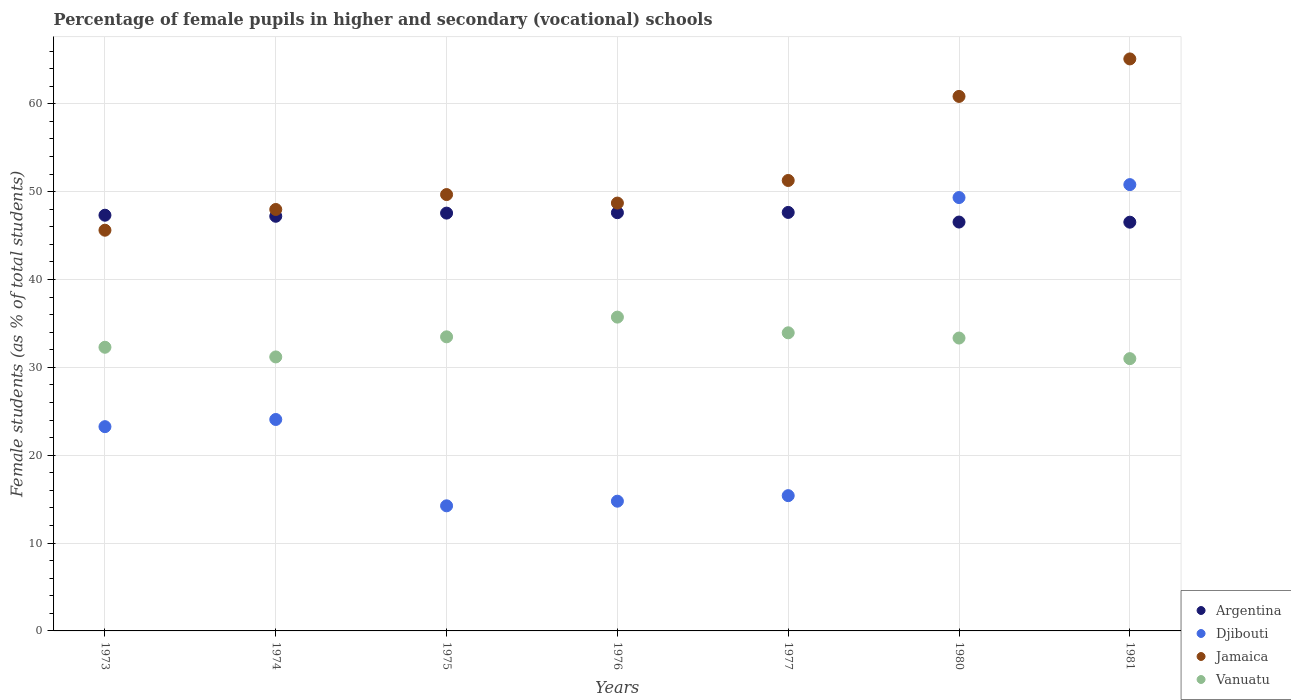How many different coloured dotlines are there?
Give a very brief answer. 4. Is the number of dotlines equal to the number of legend labels?
Your answer should be very brief. Yes. What is the percentage of female pupils in higher and secondary schools in Argentina in 1974?
Ensure brevity in your answer.  47.19. Across all years, what is the maximum percentage of female pupils in higher and secondary schools in Vanuatu?
Offer a terse response. 35.71. Across all years, what is the minimum percentage of female pupils in higher and secondary schools in Vanuatu?
Give a very brief answer. 30.99. In which year was the percentage of female pupils in higher and secondary schools in Djibouti maximum?
Give a very brief answer. 1981. In which year was the percentage of female pupils in higher and secondary schools in Jamaica minimum?
Ensure brevity in your answer.  1973. What is the total percentage of female pupils in higher and secondary schools in Djibouti in the graph?
Provide a succinct answer. 191.83. What is the difference between the percentage of female pupils in higher and secondary schools in Djibouti in 1976 and that in 1981?
Keep it short and to the point. -36.03. What is the difference between the percentage of female pupils in higher and secondary schools in Argentina in 1981 and the percentage of female pupils in higher and secondary schools in Vanuatu in 1977?
Your answer should be compact. 12.59. What is the average percentage of female pupils in higher and secondary schools in Jamaica per year?
Your response must be concise. 52.73. In the year 1977, what is the difference between the percentage of female pupils in higher and secondary schools in Argentina and percentage of female pupils in higher and secondary schools in Vanuatu?
Ensure brevity in your answer.  13.7. In how many years, is the percentage of female pupils in higher and secondary schools in Argentina greater than 2 %?
Ensure brevity in your answer.  7. What is the ratio of the percentage of female pupils in higher and secondary schools in Vanuatu in 1975 to that in 1980?
Your response must be concise. 1. Is the percentage of female pupils in higher and secondary schools in Jamaica in 1975 less than that in 1976?
Make the answer very short. No. What is the difference between the highest and the second highest percentage of female pupils in higher and secondary schools in Jamaica?
Give a very brief answer. 4.27. What is the difference between the highest and the lowest percentage of female pupils in higher and secondary schools in Vanuatu?
Your answer should be very brief. 4.73. In how many years, is the percentage of female pupils in higher and secondary schools in Djibouti greater than the average percentage of female pupils in higher and secondary schools in Djibouti taken over all years?
Your answer should be compact. 2. Is it the case that in every year, the sum of the percentage of female pupils in higher and secondary schools in Vanuatu and percentage of female pupils in higher and secondary schools in Argentina  is greater than the sum of percentage of female pupils in higher and secondary schools in Jamaica and percentage of female pupils in higher and secondary schools in Djibouti?
Offer a very short reply. Yes. Does the percentage of female pupils in higher and secondary schools in Vanuatu monotonically increase over the years?
Make the answer very short. No. Is the percentage of female pupils in higher and secondary schools in Djibouti strictly less than the percentage of female pupils in higher and secondary schools in Jamaica over the years?
Your answer should be very brief. Yes. What is the difference between two consecutive major ticks on the Y-axis?
Offer a terse response. 10. Are the values on the major ticks of Y-axis written in scientific E-notation?
Make the answer very short. No. Does the graph contain grids?
Keep it short and to the point. Yes. What is the title of the graph?
Offer a very short reply. Percentage of female pupils in higher and secondary (vocational) schools. What is the label or title of the X-axis?
Provide a succinct answer. Years. What is the label or title of the Y-axis?
Your answer should be very brief. Female students (as % of total students). What is the Female students (as % of total students) of Argentina in 1973?
Your response must be concise. 47.31. What is the Female students (as % of total students) of Djibouti in 1973?
Your response must be concise. 23.25. What is the Female students (as % of total students) of Jamaica in 1973?
Make the answer very short. 45.61. What is the Female students (as % of total students) of Vanuatu in 1973?
Give a very brief answer. 32.28. What is the Female students (as % of total students) in Argentina in 1974?
Offer a terse response. 47.19. What is the Female students (as % of total students) of Djibouti in 1974?
Ensure brevity in your answer.  24.06. What is the Female students (as % of total students) in Jamaica in 1974?
Offer a terse response. 47.97. What is the Female students (as % of total students) of Vanuatu in 1974?
Offer a very short reply. 31.18. What is the Female students (as % of total students) in Argentina in 1975?
Provide a succinct answer. 47.55. What is the Female students (as % of total students) in Djibouti in 1975?
Ensure brevity in your answer.  14.24. What is the Female students (as % of total students) in Jamaica in 1975?
Offer a terse response. 49.66. What is the Female students (as % of total students) in Vanuatu in 1975?
Ensure brevity in your answer.  33.47. What is the Female students (as % of total students) in Argentina in 1976?
Offer a very short reply. 47.6. What is the Female students (as % of total students) of Djibouti in 1976?
Provide a short and direct response. 14.77. What is the Female students (as % of total students) of Jamaica in 1976?
Make the answer very short. 48.69. What is the Female students (as % of total students) of Vanuatu in 1976?
Your response must be concise. 35.71. What is the Female students (as % of total students) in Argentina in 1977?
Your answer should be very brief. 47.63. What is the Female students (as % of total students) in Djibouti in 1977?
Provide a short and direct response. 15.4. What is the Female students (as % of total students) of Jamaica in 1977?
Provide a short and direct response. 51.27. What is the Female students (as % of total students) in Vanuatu in 1977?
Your answer should be very brief. 33.93. What is the Female students (as % of total students) of Argentina in 1980?
Ensure brevity in your answer.  46.53. What is the Female students (as % of total students) in Djibouti in 1980?
Your answer should be compact. 49.32. What is the Female students (as % of total students) of Jamaica in 1980?
Make the answer very short. 60.83. What is the Female students (as % of total students) of Vanuatu in 1980?
Offer a terse response. 33.33. What is the Female students (as % of total students) in Argentina in 1981?
Make the answer very short. 46.52. What is the Female students (as % of total students) in Djibouti in 1981?
Ensure brevity in your answer.  50.79. What is the Female students (as % of total students) of Jamaica in 1981?
Give a very brief answer. 65.1. What is the Female students (as % of total students) of Vanuatu in 1981?
Your answer should be compact. 30.99. Across all years, what is the maximum Female students (as % of total students) of Argentina?
Offer a terse response. 47.63. Across all years, what is the maximum Female students (as % of total students) in Djibouti?
Offer a terse response. 50.79. Across all years, what is the maximum Female students (as % of total students) of Jamaica?
Offer a very short reply. 65.1. Across all years, what is the maximum Female students (as % of total students) in Vanuatu?
Your answer should be compact. 35.71. Across all years, what is the minimum Female students (as % of total students) of Argentina?
Your answer should be compact. 46.52. Across all years, what is the minimum Female students (as % of total students) of Djibouti?
Keep it short and to the point. 14.24. Across all years, what is the minimum Female students (as % of total students) of Jamaica?
Your answer should be compact. 45.61. Across all years, what is the minimum Female students (as % of total students) in Vanuatu?
Give a very brief answer. 30.99. What is the total Female students (as % of total students) in Argentina in the graph?
Offer a very short reply. 330.34. What is the total Female students (as % of total students) in Djibouti in the graph?
Provide a short and direct response. 191.83. What is the total Female students (as % of total students) in Jamaica in the graph?
Offer a very short reply. 369.13. What is the total Female students (as % of total students) in Vanuatu in the graph?
Provide a succinct answer. 230.9. What is the difference between the Female students (as % of total students) of Argentina in 1973 and that in 1974?
Your answer should be very brief. 0.12. What is the difference between the Female students (as % of total students) of Djibouti in 1973 and that in 1974?
Keep it short and to the point. -0.82. What is the difference between the Female students (as % of total students) of Jamaica in 1973 and that in 1974?
Offer a terse response. -2.36. What is the difference between the Female students (as % of total students) of Vanuatu in 1973 and that in 1974?
Keep it short and to the point. 1.1. What is the difference between the Female students (as % of total students) in Argentina in 1973 and that in 1975?
Provide a succinct answer. -0.24. What is the difference between the Female students (as % of total students) of Djibouti in 1973 and that in 1975?
Your response must be concise. 9.01. What is the difference between the Female students (as % of total students) in Jamaica in 1973 and that in 1975?
Offer a very short reply. -4.06. What is the difference between the Female students (as % of total students) of Vanuatu in 1973 and that in 1975?
Give a very brief answer. -1.19. What is the difference between the Female students (as % of total students) of Argentina in 1973 and that in 1976?
Your answer should be compact. -0.29. What is the difference between the Female students (as % of total students) of Djibouti in 1973 and that in 1976?
Give a very brief answer. 8.48. What is the difference between the Female students (as % of total students) of Jamaica in 1973 and that in 1976?
Keep it short and to the point. -3.09. What is the difference between the Female students (as % of total students) in Vanuatu in 1973 and that in 1976?
Make the answer very short. -3.43. What is the difference between the Female students (as % of total students) in Argentina in 1973 and that in 1977?
Provide a short and direct response. -0.32. What is the difference between the Female students (as % of total students) in Djibouti in 1973 and that in 1977?
Make the answer very short. 7.85. What is the difference between the Female students (as % of total students) in Jamaica in 1973 and that in 1977?
Give a very brief answer. -5.66. What is the difference between the Female students (as % of total students) of Vanuatu in 1973 and that in 1977?
Give a very brief answer. -1.65. What is the difference between the Female students (as % of total students) of Argentina in 1973 and that in 1980?
Ensure brevity in your answer.  0.78. What is the difference between the Female students (as % of total students) in Djibouti in 1973 and that in 1980?
Your response must be concise. -26.07. What is the difference between the Female students (as % of total students) in Jamaica in 1973 and that in 1980?
Your response must be concise. -15.23. What is the difference between the Female students (as % of total students) of Vanuatu in 1973 and that in 1980?
Offer a very short reply. -1.05. What is the difference between the Female students (as % of total students) of Argentina in 1973 and that in 1981?
Make the answer very short. 0.79. What is the difference between the Female students (as % of total students) in Djibouti in 1973 and that in 1981?
Provide a short and direct response. -27.55. What is the difference between the Female students (as % of total students) in Jamaica in 1973 and that in 1981?
Your response must be concise. -19.49. What is the difference between the Female students (as % of total students) of Vanuatu in 1973 and that in 1981?
Provide a short and direct response. 1.3. What is the difference between the Female students (as % of total students) in Argentina in 1974 and that in 1975?
Offer a very short reply. -0.36. What is the difference between the Female students (as % of total students) of Djibouti in 1974 and that in 1975?
Make the answer very short. 9.83. What is the difference between the Female students (as % of total students) of Jamaica in 1974 and that in 1975?
Make the answer very short. -1.7. What is the difference between the Female students (as % of total students) in Vanuatu in 1974 and that in 1975?
Your response must be concise. -2.29. What is the difference between the Female students (as % of total students) in Argentina in 1974 and that in 1976?
Your answer should be compact. -0.41. What is the difference between the Female students (as % of total students) of Djibouti in 1974 and that in 1976?
Your answer should be compact. 9.3. What is the difference between the Female students (as % of total students) of Jamaica in 1974 and that in 1976?
Your answer should be very brief. -0.73. What is the difference between the Female students (as % of total students) in Vanuatu in 1974 and that in 1976?
Your answer should be compact. -4.53. What is the difference between the Female students (as % of total students) in Argentina in 1974 and that in 1977?
Provide a short and direct response. -0.44. What is the difference between the Female students (as % of total students) of Djibouti in 1974 and that in 1977?
Your answer should be compact. 8.67. What is the difference between the Female students (as % of total students) of Jamaica in 1974 and that in 1977?
Ensure brevity in your answer.  -3.3. What is the difference between the Female students (as % of total students) of Vanuatu in 1974 and that in 1977?
Offer a terse response. -2.75. What is the difference between the Female students (as % of total students) in Argentina in 1974 and that in 1980?
Offer a terse response. 0.66. What is the difference between the Female students (as % of total students) in Djibouti in 1974 and that in 1980?
Provide a succinct answer. -25.26. What is the difference between the Female students (as % of total students) of Jamaica in 1974 and that in 1980?
Your response must be concise. -12.87. What is the difference between the Female students (as % of total students) in Vanuatu in 1974 and that in 1980?
Give a very brief answer. -2.15. What is the difference between the Female students (as % of total students) of Argentina in 1974 and that in 1981?
Offer a terse response. 0.67. What is the difference between the Female students (as % of total students) of Djibouti in 1974 and that in 1981?
Provide a succinct answer. -26.73. What is the difference between the Female students (as % of total students) in Jamaica in 1974 and that in 1981?
Your answer should be very brief. -17.13. What is the difference between the Female students (as % of total students) of Vanuatu in 1974 and that in 1981?
Offer a very short reply. 0.19. What is the difference between the Female students (as % of total students) in Argentina in 1975 and that in 1976?
Your response must be concise. -0.05. What is the difference between the Female students (as % of total students) of Djibouti in 1975 and that in 1976?
Offer a terse response. -0.53. What is the difference between the Female students (as % of total students) of Jamaica in 1975 and that in 1976?
Give a very brief answer. 0.97. What is the difference between the Female students (as % of total students) in Vanuatu in 1975 and that in 1976?
Your answer should be compact. -2.24. What is the difference between the Female students (as % of total students) in Argentina in 1975 and that in 1977?
Ensure brevity in your answer.  -0.08. What is the difference between the Female students (as % of total students) of Djibouti in 1975 and that in 1977?
Provide a short and direct response. -1.16. What is the difference between the Female students (as % of total students) of Jamaica in 1975 and that in 1977?
Give a very brief answer. -1.6. What is the difference between the Female students (as % of total students) in Vanuatu in 1975 and that in 1977?
Provide a short and direct response. -0.46. What is the difference between the Female students (as % of total students) of Argentina in 1975 and that in 1980?
Your response must be concise. 1.02. What is the difference between the Female students (as % of total students) of Djibouti in 1975 and that in 1980?
Your answer should be very brief. -35.08. What is the difference between the Female students (as % of total students) in Jamaica in 1975 and that in 1980?
Provide a succinct answer. -11.17. What is the difference between the Female students (as % of total students) of Vanuatu in 1975 and that in 1980?
Ensure brevity in your answer.  0.14. What is the difference between the Female students (as % of total students) of Argentina in 1975 and that in 1981?
Provide a succinct answer. 1.03. What is the difference between the Female students (as % of total students) of Djibouti in 1975 and that in 1981?
Keep it short and to the point. -36.56. What is the difference between the Female students (as % of total students) of Jamaica in 1975 and that in 1981?
Your answer should be compact. -15.44. What is the difference between the Female students (as % of total students) in Vanuatu in 1975 and that in 1981?
Make the answer very short. 2.48. What is the difference between the Female students (as % of total students) of Argentina in 1976 and that in 1977?
Offer a very short reply. -0.03. What is the difference between the Female students (as % of total students) in Djibouti in 1976 and that in 1977?
Give a very brief answer. -0.63. What is the difference between the Female students (as % of total students) in Jamaica in 1976 and that in 1977?
Make the answer very short. -2.57. What is the difference between the Female students (as % of total students) in Vanuatu in 1976 and that in 1977?
Keep it short and to the point. 1.79. What is the difference between the Female students (as % of total students) in Argentina in 1976 and that in 1980?
Give a very brief answer. 1.06. What is the difference between the Female students (as % of total students) in Djibouti in 1976 and that in 1980?
Offer a terse response. -34.56. What is the difference between the Female students (as % of total students) in Jamaica in 1976 and that in 1980?
Give a very brief answer. -12.14. What is the difference between the Female students (as % of total students) of Vanuatu in 1976 and that in 1980?
Make the answer very short. 2.38. What is the difference between the Female students (as % of total students) in Argentina in 1976 and that in 1981?
Make the answer very short. 1.08. What is the difference between the Female students (as % of total students) of Djibouti in 1976 and that in 1981?
Your answer should be very brief. -36.03. What is the difference between the Female students (as % of total students) of Jamaica in 1976 and that in 1981?
Offer a very short reply. -16.41. What is the difference between the Female students (as % of total students) in Vanuatu in 1976 and that in 1981?
Your answer should be very brief. 4.73. What is the difference between the Female students (as % of total students) in Argentina in 1977 and that in 1980?
Offer a terse response. 1.09. What is the difference between the Female students (as % of total students) of Djibouti in 1977 and that in 1980?
Your response must be concise. -33.93. What is the difference between the Female students (as % of total students) of Jamaica in 1977 and that in 1980?
Keep it short and to the point. -9.57. What is the difference between the Female students (as % of total students) of Vanuatu in 1977 and that in 1980?
Your response must be concise. 0.6. What is the difference between the Female students (as % of total students) of Argentina in 1977 and that in 1981?
Ensure brevity in your answer.  1.11. What is the difference between the Female students (as % of total students) in Djibouti in 1977 and that in 1981?
Give a very brief answer. -35.4. What is the difference between the Female students (as % of total students) of Jamaica in 1977 and that in 1981?
Offer a very short reply. -13.83. What is the difference between the Female students (as % of total students) of Vanuatu in 1977 and that in 1981?
Provide a short and direct response. 2.94. What is the difference between the Female students (as % of total students) in Argentina in 1980 and that in 1981?
Offer a terse response. 0.02. What is the difference between the Female students (as % of total students) of Djibouti in 1980 and that in 1981?
Your answer should be compact. -1.47. What is the difference between the Female students (as % of total students) of Jamaica in 1980 and that in 1981?
Give a very brief answer. -4.27. What is the difference between the Female students (as % of total students) in Vanuatu in 1980 and that in 1981?
Your answer should be compact. 2.35. What is the difference between the Female students (as % of total students) of Argentina in 1973 and the Female students (as % of total students) of Djibouti in 1974?
Give a very brief answer. 23.25. What is the difference between the Female students (as % of total students) in Argentina in 1973 and the Female students (as % of total students) in Jamaica in 1974?
Keep it short and to the point. -0.65. What is the difference between the Female students (as % of total students) in Argentina in 1973 and the Female students (as % of total students) in Vanuatu in 1974?
Offer a terse response. 16.13. What is the difference between the Female students (as % of total students) of Djibouti in 1973 and the Female students (as % of total students) of Jamaica in 1974?
Your answer should be very brief. -24.72. What is the difference between the Female students (as % of total students) in Djibouti in 1973 and the Female students (as % of total students) in Vanuatu in 1974?
Provide a short and direct response. -7.93. What is the difference between the Female students (as % of total students) of Jamaica in 1973 and the Female students (as % of total students) of Vanuatu in 1974?
Give a very brief answer. 14.42. What is the difference between the Female students (as % of total students) in Argentina in 1973 and the Female students (as % of total students) in Djibouti in 1975?
Keep it short and to the point. 33.07. What is the difference between the Female students (as % of total students) of Argentina in 1973 and the Female students (as % of total students) of Jamaica in 1975?
Your answer should be very brief. -2.35. What is the difference between the Female students (as % of total students) of Argentina in 1973 and the Female students (as % of total students) of Vanuatu in 1975?
Offer a very short reply. 13.84. What is the difference between the Female students (as % of total students) of Djibouti in 1973 and the Female students (as % of total students) of Jamaica in 1975?
Offer a very short reply. -26.41. What is the difference between the Female students (as % of total students) in Djibouti in 1973 and the Female students (as % of total students) in Vanuatu in 1975?
Provide a short and direct response. -10.22. What is the difference between the Female students (as % of total students) in Jamaica in 1973 and the Female students (as % of total students) in Vanuatu in 1975?
Your response must be concise. 12.13. What is the difference between the Female students (as % of total students) of Argentina in 1973 and the Female students (as % of total students) of Djibouti in 1976?
Your answer should be compact. 32.55. What is the difference between the Female students (as % of total students) of Argentina in 1973 and the Female students (as % of total students) of Jamaica in 1976?
Your answer should be compact. -1.38. What is the difference between the Female students (as % of total students) of Argentina in 1973 and the Female students (as % of total students) of Vanuatu in 1976?
Provide a succinct answer. 11.6. What is the difference between the Female students (as % of total students) of Djibouti in 1973 and the Female students (as % of total students) of Jamaica in 1976?
Ensure brevity in your answer.  -25.45. What is the difference between the Female students (as % of total students) in Djibouti in 1973 and the Female students (as % of total students) in Vanuatu in 1976?
Your answer should be compact. -12.47. What is the difference between the Female students (as % of total students) in Jamaica in 1973 and the Female students (as % of total students) in Vanuatu in 1976?
Your response must be concise. 9.89. What is the difference between the Female students (as % of total students) in Argentina in 1973 and the Female students (as % of total students) in Djibouti in 1977?
Provide a short and direct response. 31.92. What is the difference between the Female students (as % of total students) in Argentina in 1973 and the Female students (as % of total students) in Jamaica in 1977?
Make the answer very short. -3.95. What is the difference between the Female students (as % of total students) in Argentina in 1973 and the Female students (as % of total students) in Vanuatu in 1977?
Provide a short and direct response. 13.38. What is the difference between the Female students (as % of total students) in Djibouti in 1973 and the Female students (as % of total students) in Jamaica in 1977?
Give a very brief answer. -28.02. What is the difference between the Female students (as % of total students) in Djibouti in 1973 and the Female students (as % of total students) in Vanuatu in 1977?
Provide a succinct answer. -10.68. What is the difference between the Female students (as % of total students) in Jamaica in 1973 and the Female students (as % of total students) in Vanuatu in 1977?
Keep it short and to the point. 11.68. What is the difference between the Female students (as % of total students) of Argentina in 1973 and the Female students (as % of total students) of Djibouti in 1980?
Offer a very short reply. -2.01. What is the difference between the Female students (as % of total students) of Argentina in 1973 and the Female students (as % of total students) of Jamaica in 1980?
Ensure brevity in your answer.  -13.52. What is the difference between the Female students (as % of total students) of Argentina in 1973 and the Female students (as % of total students) of Vanuatu in 1980?
Keep it short and to the point. 13.98. What is the difference between the Female students (as % of total students) in Djibouti in 1973 and the Female students (as % of total students) in Jamaica in 1980?
Offer a very short reply. -37.59. What is the difference between the Female students (as % of total students) of Djibouti in 1973 and the Female students (as % of total students) of Vanuatu in 1980?
Offer a terse response. -10.09. What is the difference between the Female students (as % of total students) in Jamaica in 1973 and the Female students (as % of total students) in Vanuatu in 1980?
Ensure brevity in your answer.  12.27. What is the difference between the Female students (as % of total students) in Argentina in 1973 and the Female students (as % of total students) in Djibouti in 1981?
Give a very brief answer. -3.48. What is the difference between the Female students (as % of total students) in Argentina in 1973 and the Female students (as % of total students) in Jamaica in 1981?
Keep it short and to the point. -17.79. What is the difference between the Female students (as % of total students) of Argentina in 1973 and the Female students (as % of total students) of Vanuatu in 1981?
Offer a very short reply. 16.32. What is the difference between the Female students (as % of total students) in Djibouti in 1973 and the Female students (as % of total students) in Jamaica in 1981?
Your response must be concise. -41.85. What is the difference between the Female students (as % of total students) in Djibouti in 1973 and the Female students (as % of total students) in Vanuatu in 1981?
Provide a short and direct response. -7.74. What is the difference between the Female students (as % of total students) in Jamaica in 1973 and the Female students (as % of total students) in Vanuatu in 1981?
Provide a short and direct response. 14.62. What is the difference between the Female students (as % of total students) of Argentina in 1974 and the Female students (as % of total students) of Djibouti in 1975?
Provide a succinct answer. 32.95. What is the difference between the Female students (as % of total students) in Argentina in 1974 and the Female students (as % of total students) in Jamaica in 1975?
Ensure brevity in your answer.  -2.47. What is the difference between the Female students (as % of total students) in Argentina in 1974 and the Female students (as % of total students) in Vanuatu in 1975?
Make the answer very short. 13.72. What is the difference between the Female students (as % of total students) of Djibouti in 1974 and the Female students (as % of total students) of Jamaica in 1975?
Ensure brevity in your answer.  -25.6. What is the difference between the Female students (as % of total students) of Djibouti in 1974 and the Female students (as % of total students) of Vanuatu in 1975?
Keep it short and to the point. -9.41. What is the difference between the Female students (as % of total students) in Jamaica in 1974 and the Female students (as % of total students) in Vanuatu in 1975?
Your answer should be compact. 14.49. What is the difference between the Female students (as % of total students) of Argentina in 1974 and the Female students (as % of total students) of Djibouti in 1976?
Offer a terse response. 32.43. What is the difference between the Female students (as % of total students) in Argentina in 1974 and the Female students (as % of total students) in Jamaica in 1976?
Provide a succinct answer. -1.5. What is the difference between the Female students (as % of total students) of Argentina in 1974 and the Female students (as % of total students) of Vanuatu in 1976?
Give a very brief answer. 11.48. What is the difference between the Female students (as % of total students) in Djibouti in 1974 and the Female students (as % of total students) in Jamaica in 1976?
Your response must be concise. -24.63. What is the difference between the Female students (as % of total students) of Djibouti in 1974 and the Female students (as % of total students) of Vanuatu in 1976?
Make the answer very short. -11.65. What is the difference between the Female students (as % of total students) of Jamaica in 1974 and the Female students (as % of total students) of Vanuatu in 1976?
Give a very brief answer. 12.25. What is the difference between the Female students (as % of total students) in Argentina in 1974 and the Female students (as % of total students) in Djibouti in 1977?
Give a very brief answer. 31.8. What is the difference between the Female students (as % of total students) of Argentina in 1974 and the Female students (as % of total students) of Jamaica in 1977?
Your answer should be compact. -4.07. What is the difference between the Female students (as % of total students) in Argentina in 1974 and the Female students (as % of total students) in Vanuatu in 1977?
Your answer should be compact. 13.26. What is the difference between the Female students (as % of total students) in Djibouti in 1974 and the Female students (as % of total students) in Jamaica in 1977?
Offer a terse response. -27.2. What is the difference between the Female students (as % of total students) of Djibouti in 1974 and the Female students (as % of total students) of Vanuatu in 1977?
Keep it short and to the point. -9.86. What is the difference between the Female students (as % of total students) of Jamaica in 1974 and the Female students (as % of total students) of Vanuatu in 1977?
Provide a short and direct response. 14.04. What is the difference between the Female students (as % of total students) of Argentina in 1974 and the Female students (as % of total students) of Djibouti in 1980?
Make the answer very short. -2.13. What is the difference between the Female students (as % of total students) of Argentina in 1974 and the Female students (as % of total students) of Jamaica in 1980?
Ensure brevity in your answer.  -13.64. What is the difference between the Female students (as % of total students) of Argentina in 1974 and the Female students (as % of total students) of Vanuatu in 1980?
Your answer should be very brief. 13.86. What is the difference between the Female students (as % of total students) of Djibouti in 1974 and the Female students (as % of total students) of Jamaica in 1980?
Your answer should be very brief. -36.77. What is the difference between the Female students (as % of total students) in Djibouti in 1974 and the Female students (as % of total students) in Vanuatu in 1980?
Your response must be concise. -9.27. What is the difference between the Female students (as % of total students) in Jamaica in 1974 and the Female students (as % of total students) in Vanuatu in 1980?
Your response must be concise. 14.63. What is the difference between the Female students (as % of total students) in Argentina in 1974 and the Female students (as % of total students) in Djibouti in 1981?
Your answer should be compact. -3.6. What is the difference between the Female students (as % of total students) in Argentina in 1974 and the Female students (as % of total students) in Jamaica in 1981?
Offer a very short reply. -17.91. What is the difference between the Female students (as % of total students) in Argentina in 1974 and the Female students (as % of total students) in Vanuatu in 1981?
Your answer should be very brief. 16.2. What is the difference between the Female students (as % of total students) of Djibouti in 1974 and the Female students (as % of total students) of Jamaica in 1981?
Offer a very short reply. -41.04. What is the difference between the Female students (as % of total students) in Djibouti in 1974 and the Female students (as % of total students) in Vanuatu in 1981?
Your response must be concise. -6.92. What is the difference between the Female students (as % of total students) of Jamaica in 1974 and the Female students (as % of total students) of Vanuatu in 1981?
Provide a short and direct response. 16.98. What is the difference between the Female students (as % of total students) of Argentina in 1975 and the Female students (as % of total students) of Djibouti in 1976?
Make the answer very short. 32.79. What is the difference between the Female students (as % of total students) of Argentina in 1975 and the Female students (as % of total students) of Jamaica in 1976?
Offer a very short reply. -1.14. What is the difference between the Female students (as % of total students) in Argentina in 1975 and the Female students (as % of total students) in Vanuatu in 1976?
Your answer should be very brief. 11.84. What is the difference between the Female students (as % of total students) of Djibouti in 1975 and the Female students (as % of total students) of Jamaica in 1976?
Provide a succinct answer. -34.46. What is the difference between the Female students (as % of total students) of Djibouti in 1975 and the Female students (as % of total students) of Vanuatu in 1976?
Your response must be concise. -21.48. What is the difference between the Female students (as % of total students) of Jamaica in 1975 and the Female students (as % of total students) of Vanuatu in 1976?
Make the answer very short. 13.95. What is the difference between the Female students (as % of total students) of Argentina in 1975 and the Female students (as % of total students) of Djibouti in 1977?
Your answer should be compact. 32.16. What is the difference between the Female students (as % of total students) of Argentina in 1975 and the Female students (as % of total students) of Jamaica in 1977?
Offer a very short reply. -3.71. What is the difference between the Female students (as % of total students) in Argentina in 1975 and the Female students (as % of total students) in Vanuatu in 1977?
Ensure brevity in your answer.  13.62. What is the difference between the Female students (as % of total students) of Djibouti in 1975 and the Female students (as % of total students) of Jamaica in 1977?
Make the answer very short. -37.03. What is the difference between the Female students (as % of total students) of Djibouti in 1975 and the Female students (as % of total students) of Vanuatu in 1977?
Make the answer very short. -19.69. What is the difference between the Female students (as % of total students) in Jamaica in 1975 and the Female students (as % of total students) in Vanuatu in 1977?
Provide a succinct answer. 15.73. What is the difference between the Female students (as % of total students) in Argentina in 1975 and the Female students (as % of total students) in Djibouti in 1980?
Your response must be concise. -1.77. What is the difference between the Female students (as % of total students) of Argentina in 1975 and the Female students (as % of total students) of Jamaica in 1980?
Provide a short and direct response. -13.28. What is the difference between the Female students (as % of total students) of Argentina in 1975 and the Female students (as % of total students) of Vanuatu in 1980?
Make the answer very short. 14.22. What is the difference between the Female students (as % of total students) in Djibouti in 1975 and the Female students (as % of total students) in Jamaica in 1980?
Offer a terse response. -46.59. What is the difference between the Female students (as % of total students) of Djibouti in 1975 and the Female students (as % of total students) of Vanuatu in 1980?
Provide a short and direct response. -19.09. What is the difference between the Female students (as % of total students) in Jamaica in 1975 and the Female students (as % of total students) in Vanuatu in 1980?
Give a very brief answer. 16.33. What is the difference between the Female students (as % of total students) in Argentina in 1975 and the Female students (as % of total students) in Djibouti in 1981?
Your response must be concise. -3.24. What is the difference between the Female students (as % of total students) of Argentina in 1975 and the Female students (as % of total students) of Jamaica in 1981?
Ensure brevity in your answer.  -17.55. What is the difference between the Female students (as % of total students) in Argentina in 1975 and the Female students (as % of total students) in Vanuatu in 1981?
Give a very brief answer. 16.56. What is the difference between the Female students (as % of total students) in Djibouti in 1975 and the Female students (as % of total students) in Jamaica in 1981?
Offer a terse response. -50.86. What is the difference between the Female students (as % of total students) in Djibouti in 1975 and the Female students (as % of total students) in Vanuatu in 1981?
Give a very brief answer. -16.75. What is the difference between the Female students (as % of total students) in Jamaica in 1975 and the Female students (as % of total students) in Vanuatu in 1981?
Make the answer very short. 18.67. What is the difference between the Female students (as % of total students) in Argentina in 1976 and the Female students (as % of total students) in Djibouti in 1977?
Make the answer very short. 32.2. What is the difference between the Female students (as % of total students) in Argentina in 1976 and the Female students (as % of total students) in Jamaica in 1977?
Ensure brevity in your answer.  -3.67. What is the difference between the Female students (as % of total students) in Argentina in 1976 and the Female students (as % of total students) in Vanuatu in 1977?
Your response must be concise. 13.67. What is the difference between the Female students (as % of total students) in Djibouti in 1976 and the Female students (as % of total students) in Jamaica in 1977?
Provide a short and direct response. -36.5. What is the difference between the Female students (as % of total students) of Djibouti in 1976 and the Female students (as % of total students) of Vanuatu in 1977?
Provide a short and direct response. -19.16. What is the difference between the Female students (as % of total students) in Jamaica in 1976 and the Female students (as % of total students) in Vanuatu in 1977?
Your answer should be very brief. 14.77. What is the difference between the Female students (as % of total students) in Argentina in 1976 and the Female students (as % of total students) in Djibouti in 1980?
Your response must be concise. -1.72. What is the difference between the Female students (as % of total students) of Argentina in 1976 and the Female students (as % of total students) of Jamaica in 1980?
Your answer should be very brief. -13.23. What is the difference between the Female students (as % of total students) of Argentina in 1976 and the Female students (as % of total students) of Vanuatu in 1980?
Your response must be concise. 14.26. What is the difference between the Female students (as % of total students) in Djibouti in 1976 and the Female students (as % of total students) in Jamaica in 1980?
Your answer should be very brief. -46.07. What is the difference between the Female students (as % of total students) of Djibouti in 1976 and the Female students (as % of total students) of Vanuatu in 1980?
Make the answer very short. -18.57. What is the difference between the Female students (as % of total students) of Jamaica in 1976 and the Female students (as % of total students) of Vanuatu in 1980?
Make the answer very short. 15.36. What is the difference between the Female students (as % of total students) in Argentina in 1976 and the Female students (as % of total students) in Djibouti in 1981?
Your answer should be very brief. -3.2. What is the difference between the Female students (as % of total students) of Argentina in 1976 and the Female students (as % of total students) of Jamaica in 1981?
Make the answer very short. -17.5. What is the difference between the Female students (as % of total students) in Argentina in 1976 and the Female students (as % of total students) in Vanuatu in 1981?
Give a very brief answer. 16.61. What is the difference between the Female students (as % of total students) of Djibouti in 1976 and the Female students (as % of total students) of Jamaica in 1981?
Provide a succinct answer. -50.34. What is the difference between the Female students (as % of total students) of Djibouti in 1976 and the Female students (as % of total students) of Vanuatu in 1981?
Your answer should be very brief. -16.22. What is the difference between the Female students (as % of total students) in Jamaica in 1976 and the Female students (as % of total students) in Vanuatu in 1981?
Your answer should be very brief. 17.71. What is the difference between the Female students (as % of total students) of Argentina in 1977 and the Female students (as % of total students) of Djibouti in 1980?
Provide a short and direct response. -1.69. What is the difference between the Female students (as % of total students) of Argentina in 1977 and the Female students (as % of total students) of Jamaica in 1980?
Offer a very short reply. -13.2. What is the difference between the Female students (as % of total students) of Argentina in 1977 and the Female students (as % of total students) of Vanuatu in 1980?
Offer a terse response. 14.3. What is the difference between the Female students (as % of total students) of Djibouti in 1977 and the Female students (as % of total students) of Jamaica in 1980?
Provide a succinct answer. -45.44. What is the difference between the Female students (as % of total students) of Djibouti in 1977 and the Female students (as % of total students) of Vanuatu in 1980?
Provide a succinct answer. -17.94. What is the difference between the Female students (as % of total students) in Jamaica in 1977 and the Female students (as % of total students) in Vanuatu in 1980?
Your answer should be compact. 17.93. What is the difference between the Female students (as % of total students) of Argentina in 1977 and the Female students (as % of total students) of Djibouti in 1981?
Make the answer very short. -3.17. What is the difference between the Female students (as % of total students) in Argentina in 1977 and the Female students (as % of total students) in Jamaica in 1981?
Make the answer very short. -17.47. What is the difference between the Female students (as % of total students) in Argentina in 1977 and the Female students (as % of total students) in Vanuatu in 1981?
Provide a short and direct response. 16.64. What is the difference between the Female students (as % of total students) in Djibouti in 1977 and the Female students (as % of total students) in Jamaica in 1981?
Your answer should be compact. -49.7. What is the difference between the Female students (as % of total students) of Djibouti in 1977 and the Female students (as % of total students) of Vanuatu in 1981?
Your response must be concise. -15.59. What is the difference between the Female students (as % of total students) of Jamaica in 1977 and the Female students (as % of total students) of Vanuatu in 1981?
Keep it short and to the point. 20.28. What is the difference between the Female students (as % of total students) of Argentina in 1980 and the Female students (as % of total students) of Djibouti in 1981?
Your answer should be compact. -4.26. What is the difference between the Female students (as % of total students) of Argentina in 1980 and the Female students (as % of total students) of Jamaica in 1981?
Your answer should be very brief. -18.57. What is the difference between the Female students (as % of total students) in Argentina in 1980 and the Female students (as % of total students) in Vanuatu in 1981?
Your response must be concise. 15.55. What is the difference between the Female students (as % of total students) in Djibouti in 1980 and the Female students (as % of total students) in Jamaica in 1981?
Ensure brevity in your answer.  -15.78. What is the difference between the Female students (as % of total students) of Djibouti in 1980 and the Female students (as % of total students) of Vanuatu in 1981?
Offer a very short reply. 18.33. What is the difference between the Female students (as % of total students) of Jamaica in 1980 and the Female students (as % of total students) of Vanuatu in 1981?
Keep it short and to the point. 29.84. What is the average Female students (as % of total students) in Argentina per year?
Offer a terse response. 47.19. What is the average Female students (as % of total students) of Djibouti per year?
Make the answer very short. 27.4. What is the average Female students (as % of total students) of Jamaica per year?
Give a very brief answer. 52.73. What is the average Female students (as % of total students) in Vanuatu per year?
Make the answer very short. 32.99. In the year 1973, what is the difference between the Female students (as % of total students) of Argentina and Female students (as % of total students) of Djibouti?
Provide a short and direct response. 24.06. In the year 1973, what is the difference between the Female students (as % of total students) in Argentina and Female students (as % of total students) in Jamaica?
Give a very brief answer. 1.71. In the year 1973, what is the difference between the Female students (as % of total students) in Argentina and Female students (as % of total students) in Vanuatu?
Keep it short and to the point. 15.03. In the year 1973, what is the difference between the Female students (as % of total students) of Djibouti and Female students (as % of total students) of Jamaica?
Your answer should be compact. -22.36. In the year 1973, what is the difference between the Female students (as % of total students) of Djibouti and Female students (as % of total students) of Vanuatu?
Your answer should be very brief. -9.04. In the year 1973, what is the difference between the Female students (as % of total students) of Jamaica and Female students (as % of total students) of Vanuatu?
Offer a terse response. 13.32. In the year 1974, what is the difference between the Female students (as % of total students) in Argentina and Female students (as % of total students) in Djibouti?
Your answer should be very brief. 23.13. In the year 1974, what is the difference between the Female students (as % of total students) of Argentina and Female students (as % of total students) of Jamaica?
Your answer should be very brief. -0.77. In the year 1974, what is the difference between the Female students (as % of total students) of Argentina and Female students (as % of total students) of Vanuatu?
Make the answer very short. 16.01. In the year 1974, what is the difference between the Female students (as % of total students) in Djibouti and Female students (as % of total students) in Jamaica?
Ensure brevity in your answer.  -23.9. In the year 1974, what is the difference between the Female students (as % of total students) of Djibouti and Female students (as % of total students) of Vanuatu?
Your answer should be very brief. -7.12. In the year 1974, what is the difference between the Female students (as % of total students) of Jamaica and Female students (as % of total students) of Vanuatu?
Your response must be concise. 16.78. In the year 1975, what is the difference between the Female students (as % of total students) in Argentina and Female students (as % of total students) in Djibouti?
Offer a very short reply. 33.31. In the year 1975, what is the difference between the Female students (as % of total students) of Argentina and Female students (as % of total students) of Jamaica?
Provide a succinct answer. -2.11. In the year 1975, what is the difference between the Female students (as % of total students) of Argentina and Female students (as % of total students) of Vanuatu?
Your answer should be very brief. 14.08. In the year 1975, what is the difference between the Female students (as % of total students) of Djibouti and Female students (as % of total students) of Jamaica?
Offer a very short reply. -35.42. In the year 1975, what is the difference between the Female students (as % of total students) of Djibouti and Female students (as % of total students) of Vanuatu?
Provide a short and direct response. -19.23. In the year 1975, what is the difference between the Female students (as % of total students) of Jamaica and Female students (as % of total students) of Vanuatu?
Offer a terse response. 16.19. In the year 1976, what is the difference between the Female students (as % of total students) in Argentina and Female students (as % of total students) in Djibouti?
Ensure brevity in your answer.  32.83. In the year 1976, what is the difference between the Female students (as % of total students) in Argentina and Female students (as % of total students) in Jamaica?
Your answer should be compact. -1.1. In the year 1976, what is the difference between the Female students (as % of total students) in Argentina and Female students (as % of total students) in Vanuatu?
Provide a short and direct response. 11.88. In the year 1976, what is the difference between the Female students (as % of total students) of Djibouti and Female students (as % of total students) of Jamaica?
Your response must be concise. -33.93. In the year 1976, what is the difference between the Female students (as % of total students) of Djibouti and Female students (as % of total students) of Vanuatu?
Provide a succinct answer. -20.95. In the year 1976, what is the difference between the Female students (as % of total students) in Jamaica and Female students (as % of total students) in Vanuatu?
Give a very brief answer. 12.98. In the year 1977, what is the difference between the Female students (as % of total students) in Argentina and Female students (as % of total students) in Djibouti?
Your answer should be very brief. 32.23. In the year 1977, what is the difference between the Female students (as % of total students) in Argentina and Female students (as % of total students) in Jamaica?
Keep it short and to the point. -3.64. In the year 1977, what is the difference between the Female students (as % of total students) in Argentina and Female students (as % of total students) in Vanuatu?
Give a very brief answer. 13.7. In the year 1977, what is the difference between the Female students (as % of total students) of Djibouti and Female students (as % of total students) of Jamaica?
Provide a short and direct response. -35.87. In the year 1977, what is the difference between the Female students (as % of total students) in Djibouti and Female students (as % of total students) in Vanuatu?
Make the answer very short. -18.53. In the year 1977, what is the difference between the Female students (as % of total students) of Jamaica and Female students (as % of total students) of Vanuatu?
Give a very brief answer. 17.34. In the year 1980, what is the difference between the Female students (as % of total students) in Argentina and Female students (as % of total students) in Djibouti?
Provide a succinct answer. -2.79. In the year 1980, what is the difference between the Female students (as % of total students) in Argentina and Female students (as % of total students) in Jamaica?
Your response must be concise. -14.3. In the year 1980, what is the difference between the Female students (as % of total students) of Argentina and Female students (as % of total students) of Vanuatu?
Offer a very short reply. 13.2. In the year 1980, what is the difference between the Female students (as % of total students) in Djibouti and Female students (as % of total students) in Jamaica?
Ensure brevity in your answer.  -11.51. In the year 1980, what is the difference between the Female students (as % of total students) of Djibouti and Female students (as % of total students) of Vanuatu?
Ensure brevity in your answer.  15.99. In the year 1980, what is the difference between the Female students (as % of total students) of Jamaica and Female students (as % of total students) of Vanuatu?
Keep it short and to the point. 27.5. In the year 1981, what is the difference between the Female students (as % of total students) in Argentina and Female students (as % of total students) in Djibouti?
Keep it short and to the point. -4.28. In the year 1981, what is the difference between the Female students (as % of total students) in Argentina and Female students (as % of total students) in Jamaica?
Your response must be concise. -18.58. In the year 1981, what is the difference between the Female students (as % of total students) of Argentina and Female students (as % of total students) of Vanuatu?
Give a very brief answer. 15.53. In the year 1981, what is the difference between the Female students (as % of total students) in Djibouti and Female students (as % of total students) in Jamaica?
Provide a succinct answer. -14.31. In the year 1981, what is the difference between the Female students (as % of total students) of Djibouti and Female students (as % of total students) of Vanuatu?
Offer a very short reply. 19.81. In the year 1981, what is the difference between the Female students (as % of total students) of Jamaica and Female students (as % of total students) of Vanuatu?
Keep it short and to the point. 34.11. What is the ratio of the Female students (as % of total students) in Djibouti in 1973 to that in 1974?
Offer a very short reply. 0.97. What is the ratio of the Female students (as % of total students) in Jamaica in 1973 to that in 1974?
Your answer should be very brief. 0.95. What is the ratio of the Female students (as % of total students) in Vanuatu in 1973 to that in 1974?
Provide a short and direct response. 1.04. What is the ratio of the Female students (as % of total students) of Djibouti in 1973 to that in 1975?
Ensure brevity in your answer.  1.63. What is the ratio of the Female students (as % of total students) in Jamaica in 1973 to that in 1975?
Offer a very short reply. 0.92. What is the ratio of the Female students (as % of total students) of Vanuatu in 1973 to that in 1975?
Keep it short and to the point. 0.96. What is the ratio of the Female students (as % of total students) of Djibouti in 1973 to that in 1976?
Offer a very short reply. 1.57. What is the ratio of the Female students (as % of total students) of Jamaica in 1973 to that in 1976?
Keep it short and to the point. 0.94. What is the ratio of the Female students (as % of total students) of Vanuatu in 1973 to that in 1976?
Make the answer very short. 0.9. What is the ratio of the Female students (as % of total students) of Djibouti in 1973 to that in 1977?
Your response must be concise. 1.51. What is the ratio of the Female students (as % of total students) in Jamaica in 1973 to that in 1977?
Give a very brief answer. 0.89. What is the ratio of the Female students (as % of total students) in Vanuatu in 1973 to that in 1977?
Make the answer very short. 0.95. What is the ratio of the Female students (as % of total students) of Argentina in 1973 to that in 1980?
Provide a succinct answer. 1.02. What is the ratio of the Female students (as % of total students) in Djibouti in 1973 to that in 1980?
Make the answer very short. 0.47. What is the ratio of the Female students (as % of total students) in Jamaica in 1973 to that in 1980?
Ensure brevity in your answer.  0.75. What is the ratio of the Female students (as % of total students) in Vanuatu in 1973 to that in 1980?
Your answer should be compact. 0.97. What is the ratio of the Female students (as % of total students) of Argentina in 1973 to that in 1981?
Keep it short and to the point. 1.02. What is the ratio of the Female students (as % of total students) of Djibouti in 1973 to that in 1981?
Provide a short and direct response. 0.46. What is the ratio of the Female students (as % of total students) of Jamaica in 1973 to that in 1981?
Your answer should be compact. 0.7. What is the ratio of the Female students (as % of total students) of Vanuatu in 1973 to that in 1981?
Offer a very short reply. 1.04. What is the ratio of the Female students (as % of total students) in Djibouti in 1974 to that in 1975?
Offer a terse response. 1.69. What is the ratio of the Female students (as % of total students) in Jamaica in 1974 to that in 1975?
Keep it short and to the point. 0.97. What is the ratio of the Female students (as % of total students) of Vanuatu in 1974 to that in 1975?
Provide a short and direct response. 0.93. What is the ratio of the Female students (as % of total students) in Argentina in 1974 to that in 1976?
Your response must be concise. 0.99. What is the ratio of the Female students (as % of total students) in Djibouti in 1974 to that in 1976?
Your answer should be very brief. 1.63. What is the ratio of the Female students (as % of total students) in Jamaica in 1974 to that in 1976?
Offer a terse response. 0.98. What is the ratio of the Female students (as % of total students) of Vanuatu in 1974 to that in 1976?
Keep it short and to the point. 0.87. What is the ratio of the Female students (as % of total students) of Argentina in 1974 to that in 1977?
Your response must be concise. 0.99. What is the ratio of the Female students (as % of total students) of Djibouti in 1974 to that in 1977?
Provide a short and direct response. 1.56. What is the ratio of the Female students (as % of total students) in Jamaica in 1974 to that in 1977?
Your answer should be compact. 0.94. What is the ratio of the Female students (as % of total students) of Vanuatu in 1974 to that in 1977?
Offer a terse response. 0.92. What is the ratio of the Female students (as % of total students) of Argentina in 1974 to that in 1980?
Provide a succinct answer. 1.01. What is the ratio of the Female students (as % of total students) in Djibouti in 1974 to that in 1980?
Your answer should be compact. 0.49. What is the ratio of the Female students (as % of total students) of Jamaica in 1974 to that in 1980?
Your answer should be compact. 0.79. What is the ratio of the Female students (as % of total students) of Vanuatu in 1974 to that in 1980?
Provide a succinct answer. 0.94. What is the ratio of the Female students (as % of total students) in Argentina in 1974 to that in 1981?
Give a very brief answer. 1.01. What is the ratio of the Female students (as % of total students) in Djibouti in 1974 to that in 1981?
Offer a terse response. 0.47. What is the ratio of the Female students (as % of total students) of Jamaica in 1974 to that in 1981?
Your response must be concise. 0.74. What is the ratio of the Female students (as % of total students) of Vanuatu in 1974 to that in 1981?
Provide a succinct answer. 1.01. What is the ratio of the Female students (as % of total students) of Argentina in 1975 to that in 1976?
Keep it short and to the point. 1. What is the ratio of the Female students (as % of total students) in Djibouti in 1975 to that in 1976?
Give a very brief answer. 0.96. What is the ratio of the Female students (as % of total students) in Jamaica in 1975 to that in 1976?
Your answer should be very brief. 1.02. What is the ratio of the Female students (as % of total students) of Vanuatu in 1975 to that in 1976?
Your answer should be very brief. 0.94. What is the ratio of the Female students (as % of total students) in Djibouti in 1975 to that in 1977?
Make the answer very short. 0.92. What is the ratio of the Female students (as % of total students) of Jamaica in 1975 to that in 1977?
Provide a succinct answer. 0.97. What is the ratio of the Female students (as % of total students) in Vanuatu in 1975 to that in 1977?
Provide a short and direct response. 0.99. What is the ratio of the Female students (as % of total students) of Argentina in 1975 to that in 1980?
Your answer should be compact. 1.02. What is the ratio of the Female students (as % of total students) of Djibouti in 1975 to that in 1980?
Provide a succinct answer. 0.29. What is the ratio of the Female students (as % of total students) of Jamaica in 1975 to that in 1980?
Your answer should be very brief. 0.82. What is the ratio of the Female students (as % of total students) of Vanuatu in 1975 to that in 1980?
Your answer should be compact. 1. What is the ratio of the Female students (as % of total students) of Argentina in 1975 to that in 1981?
Provide a short and direct response. 1.02. What is the ratio of the Female students (as % of total students) of Djibouti in 1975 to that in 1981?
Ensure brevity in your answer.  0.28. What is the ratio of the Female students (as % of total students) of Jamaica in 1975 to that in 1981?
Make the answer very short. 0.76. What is the ratio of the Female students (as % of total students) in Vanuatu in 1975 to that in 1981?
Offer a very short reply. 1.08. What is the ratio of the Female students (as % of total students) of Argentina in 1976 to that in 1977?
Offer a very short reply. 1. What is the ratio of the Female students (as % of total students) of Djibouti in 1976 to that in 1977?
Your answer should be very brief. 0.96. What is the ratio of the Female students (as % of total students) of Jamaica in 1976 to that in 1977?
Provide a short and direct response. 0.95. What is the ratio of the Female students (as % of total students) of Vanuatu in 1976 to that in 1977?
Keep it short and to the point. 1.05. What is the ratio of the Female students (as % of total students) of Argentina in 1976 to that in 1980?
Your answer should be compact. 1.02. What is the ratio of the Female students (as % of total students) of Djibouti in 1976 to that in 1980?
Your answer should be very brief. 0.3. What is the ratio of the Female students (as % of total students) of Jamaica in 1976 to that in 1980?
Ensure brevity in your answer.  0.8. What is the ratio of the Female students (as % of total students) in Vanuatu in 1976 to that in 1980?
Keep it short and to the point. 1.07. What is the ratio of the Female students (as % of total students) in Argentina in 1976 to that in 1981?
Your response must be concise. 1.02. What is the ratio of the Female students (as % of total students) in Djibouti in 1976 to that in 1981?
Offer a very short reply. 0.29. What is the ratio of the Female students (as % of total students) of Jamaica in 1976 to that in 1981?
Offer a very short reply. 0.75. What is the ratio of the Female students (as % of total students) of Vanuatu in 1976 to that in 1981?
Provide a succinct answer. 1.15. What is the ratio of the Female students (as % of total students) in Argentina in 1977 to that in 1980?
Provide a short and direct response. 1.02. What is the ratio of the Female students (as % of total students) of Djibouti in 1977 to that in 1980?
Ensure brevity in your answer.  0.31. What is the ratio of the Female students (as % of total students) of Jamaica in 1977 to that in 1980?
Give a very brief answer. 0.84. What is the ratio of the Female students (as % of total students) of Vanuatu in 1977 to that in 1980?
Offer a terse response. 1.02. What is the ratio of the Female students (as % of total students) of Argentina in 1977 to that in 1981?
Offer a terse response. 1.02. What is the ratio of the Female students (as % of total students) in Djibouti in 1977 to that in 1981?
Offer a terse response. 0.3. What is the ratio of the Female students (as % of total students) of Jamaica in 1977 to that in 1981?
Your response must be concise. 0.79. What is the ratio of the Female students (as % of total students) in Vanuatu in 1977 to that in 1981?
Your answer should be very brief. 1.09. What is the ratio of the Female students (as % of total students) of Djibouti in 1980 to that in 1981?
Offer a very short reply. 0.97. What is the ratio of the Female students (as % of total students) in Jamaica in 1980 to that in 1981?
Ensure brevity in your answer.  0.93. What is the ratio of the Female students (as % of total students) of Vanuatu in 1980 to that in 1981?
Your answer should be very brief. 1.08. What is the difference between the highest and the second highest Female students (as % of total students) of Argentina?
Offer a terse response. 0.03. What is the difference between the highest and the second highest Female students (as % of total students) of Djibouti?
Offer a very short reply. 1.47. What is the difference between the highest and the second highest Female students (as % of total students) in Jamaica?
Give a very brief answer. 4.27. What is the difference between the highest and the second highest Female students (as % of total students) of Vanuatu?
Keep it short and to the point. 1.79. What is the difference between the highest and the lowest Female students (as % of total students) of Argentina?
Your response must be concise. 1.11. What is the difference between the highest and the lowest Female students (as % of total students) of Djibouti?
Provide a succinct answer. 36.56. What is the difference between the highest and the lowest Female students (as % of total students) of Jamaica?
Your answer should be very brief. 19.49. What is the difference between the highest and the lowest Female students (as % of total students) in Vanuatu?
Offer a terse response. 4.73. 